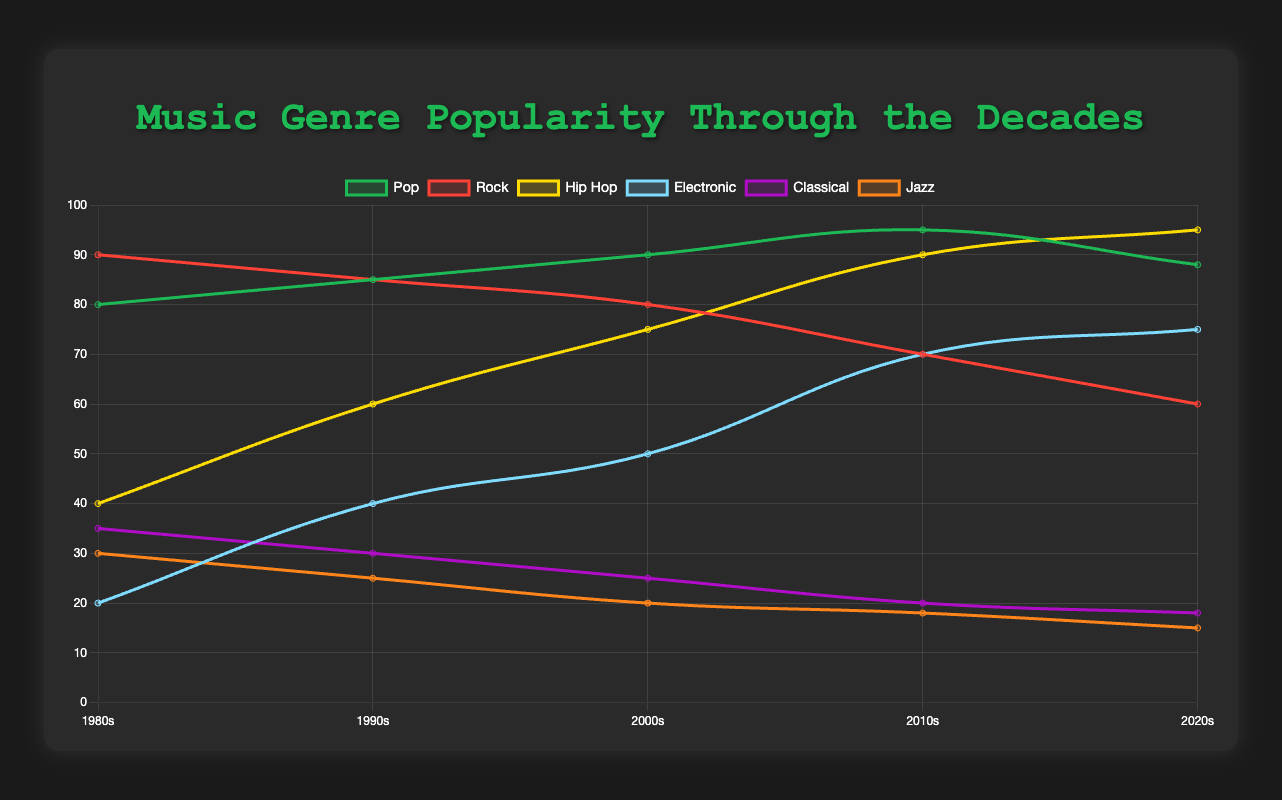What genre had the highest popularity in the 1980s? The figure shows the popularity of music genres across various decades. In the 1980s, the genre with the highest popularity is Rock with a popularity score of 90.
Answer: Rock How did the popularity of Hip Hop change from the 1990s to the 2010s? The popularity of Hip Hop increased significantly over these decades. It went from 60 in the 1990s to 90 in the 2010s, an increase of 30 points.
Answer: Increased Which genre showed the most growth from the 1980s to the 2020s? By comparing the data points of each genre from the 1980s to the 2020s, Hip Hop showed the most growth. It went from 40 in the 1980s to 95 in the 2020s, an increase of 55 points.
Answer: Hip Hop What is the average popularity of Pop music across all decades? To find the average, sum the popularity values of Pop for all decades and divide by the number of decades: (80 + 85 + 90 + 95 + 88)/5 = 87.6.
Answer: 87.6 Which genres decreased in popularity in the 2020s compared to the 2000s? By comparing the popularity in the 2000s and the 2020s, Rock, Classical, and Jazz all decreased. Rock went from 80 to 60, Classical from 25 to 18, and Jazz from 20 to 15.
Answer: Rock, Classical, Jazz In which decade did Electronic music see the greatest increase in popularity? Looking at the changes in popularity for Electronic music, the greatest increase was from the 2000s (50) to the 2010s (70), an increase of 20 points.
Answer: 2010s Which genre had a consistent decline across every decade? Both Classical and Jazz show consistent declines across each decade. Classical went from 35 to 18, and Jazz from 30 to 15.
Answer: Classical, Jazz Is the popularity trend for Pop music increasing or decreasing? The trend for Pop music shows fluctuations but generally an increasing trend up to the 2010s and a slight decrease in the 2020s. However, overall it increased from 80 in the 1980s to 88 in the 2020s.
Answer: Increasing Compare the popularity of Rock and Electronic music in the 2000s. In the 2000s, Rock had a popularity score of 80, while Electronic had a score of 50. So, Rock was more popular than Electronic by 30 points.
Answer: Rock was more popular What was the least popular genre in the 2010s? In the 2010s, among all the genres listed, Jazz was the least popular with a score of 18.
Answer: Jazz 